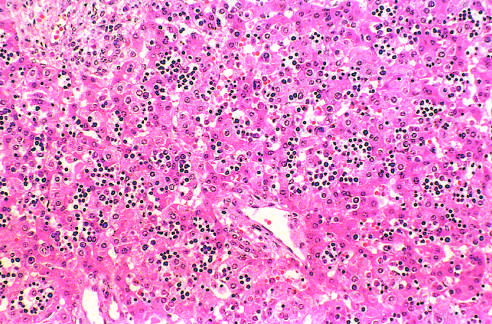re neutrophils scattered among mature hepatocytes in this histologic preparation from an infant with nonimmune hydrops fetalis?
Answer the question using a single word or phrase. No 